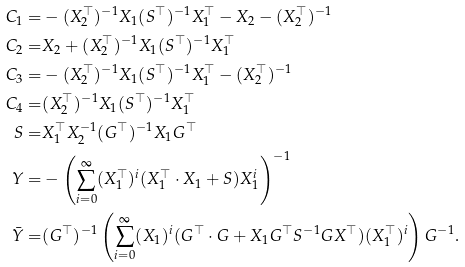Convert formula to latex. <formula><loc_0><loc_0><loc_500><loc_500>C _ { 1 } = & - ( X _ { 2 } ^ { \top } ) ^ { - 1 } X _ { 1 } ( S ^ { \top } ) ^ { - 1 } X _ { 1 } ^ { \top } - X _ { 2 } - ( X _ { 2 } ^ { \top } ) ^ { - 1 } \\ C _ { 2 } = & X _ { 2 } + ( X _ { 2 } ^ { \top } ) ^ { - 1 } X _ { 1 } ( S ^ { \top } ) ^ { - 1 } X _ { 1 } ^ { \top } \\ C _ { 3 } = & - ( X _ { 2 } ^ { \top } ) ^ { - 1 } X _ { 1 } ( S ^ { \top } ) ^ { - 1 } X _ { 1 } ^ { \top } - ( X _ { 2 } ^ { \top } ) ^ { - 1 } \\ C _ { 4 } = & ( X _ { 2 } ^ { \top } ) ^ { - 1 } X _ { 1 } ( S ^ { \top } ) ^ { - 1 } X _ { 1 } ^ { \top } \\ S = & X _ { 1 } ^ { \top } X _ { 2 } ^ { - 1 } ( G ^ { \top } ) ^ { - 1 } X _ { 1 } G ^ { \top } \\ Y = & - \left ( \sum _ { i = 0 } ^ { \infty } ( X _ { 1 } ^ { \top } ) ^ { i } ( X _ { 1 } ^ { \top } \cdot X _ { 1 } + S ) X _ { 1 } ^ { i } \right ) ^ { - 1 } \\ \bar { Y } = & ( G ^ { \top } ) ^ { - 1 } \left ( \sum _ { i = 0 } ^ { \infty } ( X _ { 1 } ) ^ { i } ( G ^ { \top } \cdot G + X _ { 1 } G ^ { \top } S ^ { - 1 } G X ^ { \top } ) ( X _ { 1 } ^ { \top } ) ^ { i } \right ) G ^ { - 1 } .</formula> 